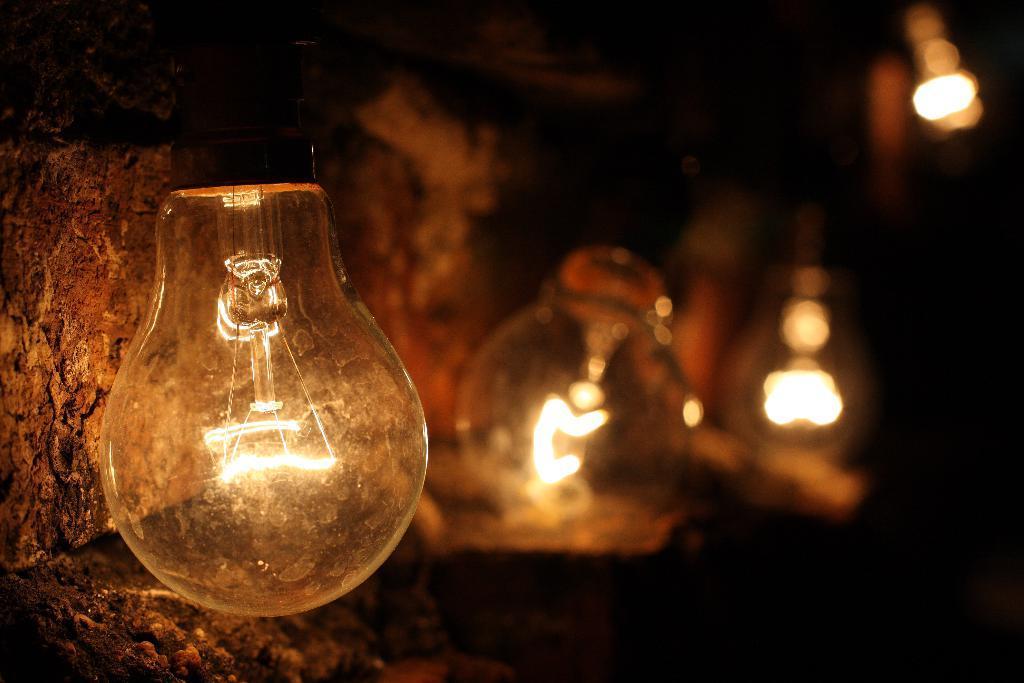Could you give a brief overview of what you see in this image? In the picture I can see few bulbs glowing and there is a wall in the left corner. 